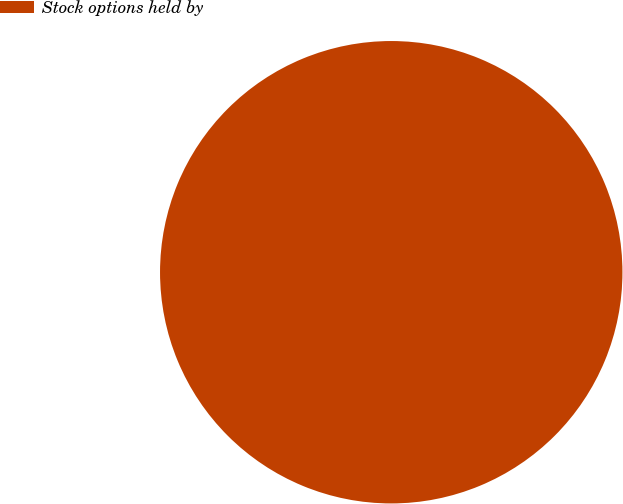<chart> <loc_0><loc_0><loc_500><loc_500><pie_chart><fcel>Stock options held by<nl><fcel>100.0%<nl></chart> 